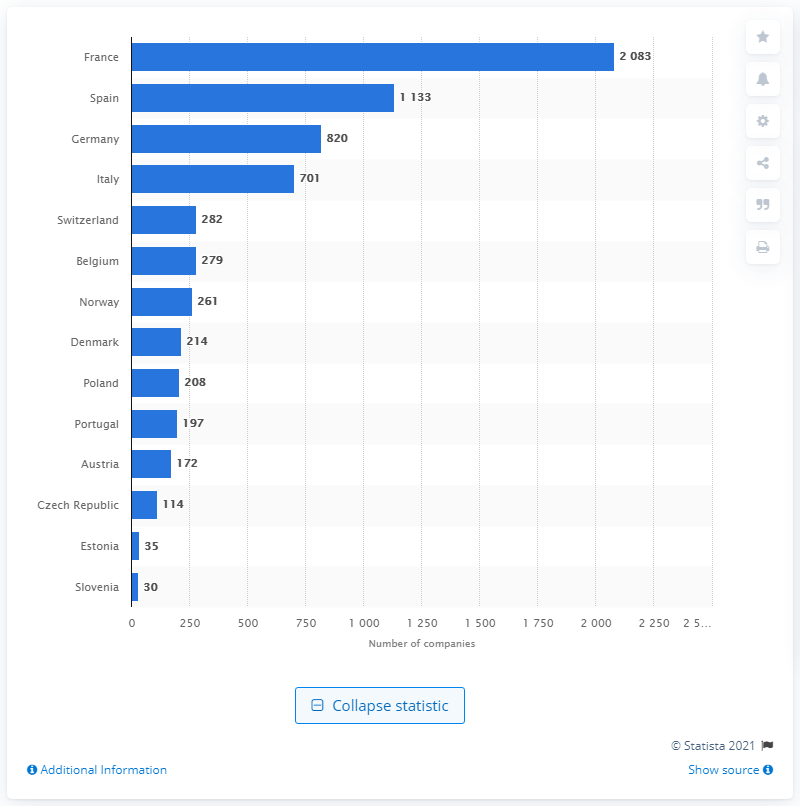Specify some key components in this picture. Spain has the second largest number of biotechnological companies. According to data from 2018, France had the largest number of biotech firms among all countries. 